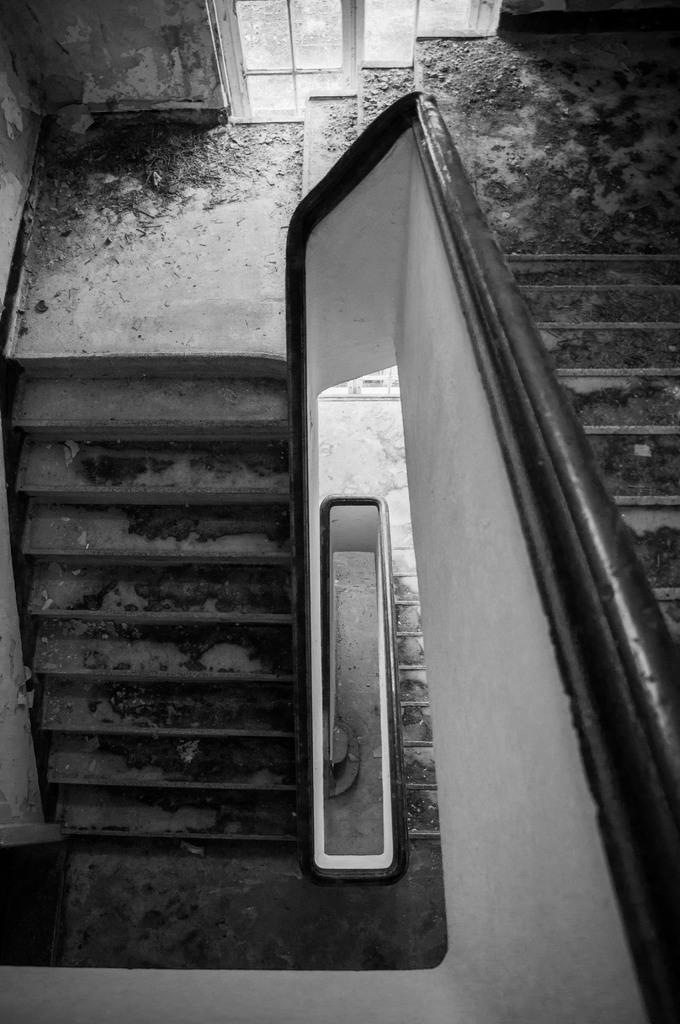What type of structure is present in the image? There is a staircase in the image. What can be seen in the background of the image? There is a wall and a window in the background of the image. What type of meal is being prepared in the image? There is no meal preparation visible in the image; it only features a staircase, a wall, and a window. 